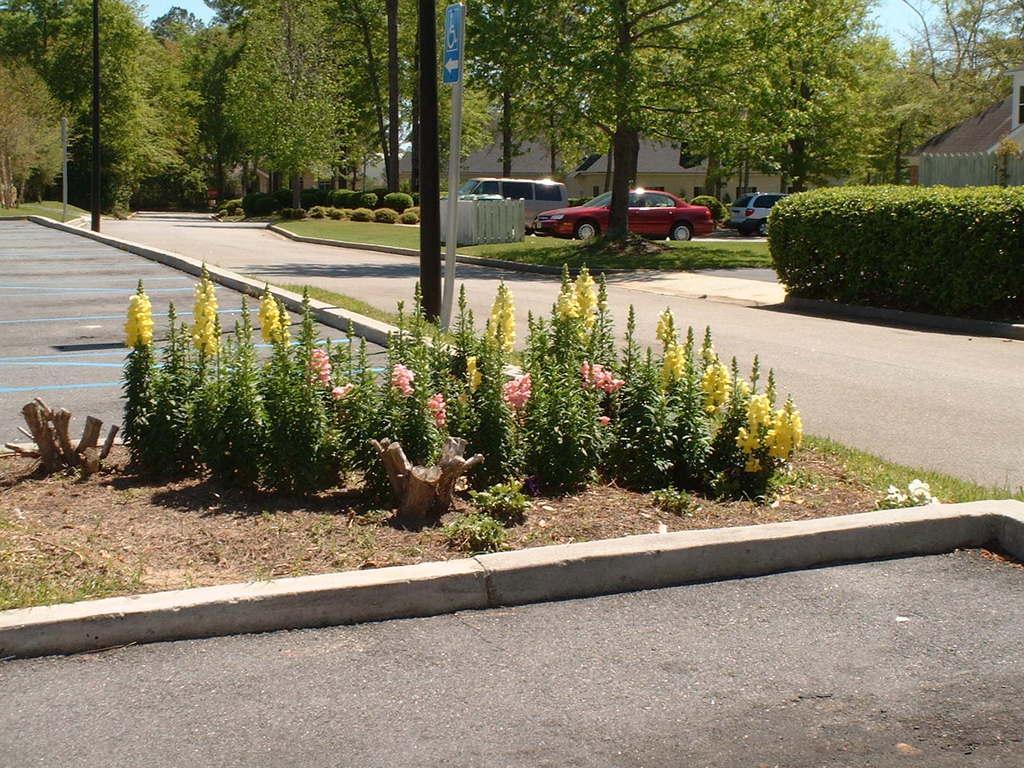In one or two sentences, can you explain what this image depicts? In this picture there are buildings and trees and there are poles. In the foreground there are flowers on the plants and there are vehicles on the road. At the top there is sky. At the bottom there is a road and there is grass. 